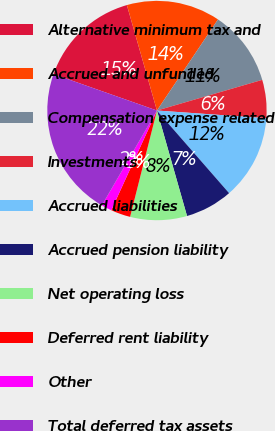Convert chart to OTSL. <chart><loc_0><loc_0><loc_500><loc_500><pie_chart><fcel>Alternative minimum tax and<fcel>Accrued and unfunded<fcel>Compensation expense related<fcel>Investments<fcel>Accrued liabilities<fcel>Accrued pension liability<fcel>Net operating loss<fcel>Deferred rent liability<fcel>Other<fcel>Total deferred tax assets<nl><fcel>15.19%<fcel>13.82%<fcel>11.09%<fcel>5.63%<fcel>12.46%<fcel>7.0%<fcel>8.36%<fcel>2.9%<fcel>1.54%<fcel>22.01%<nl></chart> 